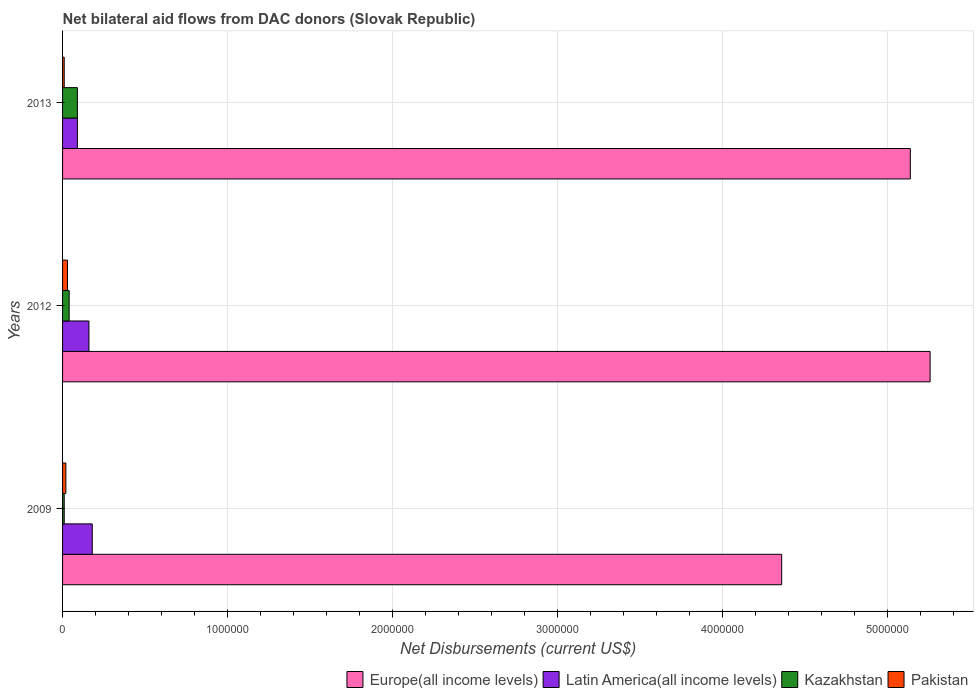How many different coloured bars are there?
Keep it short and to the point. 4. Are the number of bars per tick equal to the number of legend labels?
Provide a succinct answer. Yes. Are the number of bars on each tick of the Y-axis equal?
Your answer should be very brief. Yes. How many bars are there on the 1st tick from the bottom?
Provide a succinct answer. 4. In how many cases, is the number of bars for a given year not equal to the number of legend labels?
Keep it short and to the point. 0. Across all years, what is the maximum net bilateral aid flows in Kazakhstan?
Make the answer very short. 9.00e+04. In which year was the net bilateral aid flows in Pakistan maximum?
Your answer should be compact. 2012. In which year was the net bilateral aid flows in Pakistan minimum?
Give a very brief answer. 2013. What is the total net bilateral aid flows in Latin America(all income levels) in the graph?
Your response must be concise. 4.30e+05. What is the ratio of the net bilateral aid flows in Pakistan in 2009 to that in 2013?
Provide a succinct answer. 2. Is the difference between the net bilateral aid flows in Kazakhstan in 2009 and 2013 greater than the difference between the net bilateral aid flows in Latin America(all income levels) in 2009 and 2013?
Offer a very short reply. No. In how many years, is the net bilateral aid flows in Pakistan greater than the average net bilateral aid flows in Pakistan taken over all years?
Your response must be concise. 1. Is the sum of the net bilateral aid flows in Pakistan in 2009 and 2013 greater than the maximum net bilateral aid flows in Europe(all income levels) across all years?
Your answer should be very brief. No. Is it the case that in every year, the sum of the net bilateral aid flows in Kazakhstan and net bilateral aid flows in Pakistan is greater than the sum of net bilateral aid flows in Europe(all income levels) and net bilateral aid flows in Latin America(all income levels)?
Provide a short and direct response. No. What does the 3rd bar from the top in 2013 represents?
Your answer should be compact. Latin America(all income levels). What does the 3rd bar from the bottom in 2012 represents?
Your answer should be compact. Kazakhstan. Is it the case that in every year, the sum of the net bilateral aid flows in Latin America(all income levels) and net bilateral aid flows in Europe(all income levels) is greater than the net bilateral aid flows in Pakistan?
Your answer should be compact. Yes. How many bars are there?
Ensure brevity in your answer.  12. Are all the bars in the graph horizontal?
Keep it short and to the point. Yes. Are the values on the major ticks of X-axis written in scientific E-notation?
Your answer should be compact. No. Does the graph contain grids?
Provide a short and direct response. Yes. Where does the legend appear in the graph?
Give a very brief answer. Bottom right. How many legend labels are there?
Ensure brevity in your answer.  4. What is the title of the graph?
Provide a succinct answer. Net bilateral aid flows from DAC donors (Slovak Republic). Does "Singapore" appear as one of the legend labels in the graph?
Ensure brevity in your answer.  No. What is the label or title of the X-axis?
Provide a short and direct response. Net Disbursements (current US$). What is the Net Disbursements (current US$) of Europe(all income levels) in 2009?
Your answer should be compact. 4.36e+06. What is the Net Disbursements (current US$) of Latin America(all income levels) in 2009?
Provide a succinct answer. 1.80e+05. What is the Net Disbursements (current US$) in Kazakhstan in 2009?
Offer a terse response. 10000. What is the Net Disbursements (current US$) in Pakistan in 2009?
Make the answer very short. 2.00e+04. What is the Net Disbursements (current US$) of Europe(all income levels) in 2012?
Make the answer very short. 5.26e+06. What is the Net Disbursements (current US$) of Latin America(all income levels) in 2012?
Offer a very short reply. 1.60e+05. What is the Net Disbursements (current US$) of Kazakhstan in 2012?
Give a very brief answer. 4.00e+04. What is the Net Disbursements (current US$) of Pakistan in 2012?
Keep it short and to the point. 3.00e+04. What is the Net Disbursements (current US$) in Europe(all income levels) in 2013?
Provide a short and direct response. 5.14e+06. What is the Net Disbursements (current US$) in Pakistan in 2013?
Provide a succinct answer. 10000. Across all years, what is the maximum Net Disbursements (current US$) in Europe(all income levels)?
Keep it short and to the point. 5.26e+06. Across all years, what is the maximum Net Disbursements (current US$) of Kazakhstan?
Offer a terse response. 9.00e+04. Across all years, what is the minimum Net Disbursements (current US$) of Europe(all income levels)?
Give a very brief answer. 4.36e+06. Across all years, what is the minimum Net Disbursements (current US$) in Latin America(all income levels)?
Offer a very short reply. 9.00e+04. Across all years, what is the minimum Net Disbursements (current US$) in Kazakhstan?
Your answer should be very brief. 10000. What is the total Net Disbursements (current US$) in Europe(all income levels) in the graph?
Ensure brevity in your answer.  1.48e+07. What is the total Net Disbursements (current US$) of Kazakhstan in the graph?
Your response must be concise. 1.40e+05. What is the difference between the Net Disbursements (current US$) in Europe(all income levels) in 2009 and that in 2012?
Your answer should be very brief. -9.00e+05. What is the difference between the Net Disbursements (current US$) of Latin America(all income levels) in 2009 and that in 2012?
Your response must be concise. 2.00e+04. What is the difference between the Net Disbursements (current US$) in Kazakhstan in 2009 and that in 2012?
Keep it short and to the point. -3.00e+04. What is the difference between the Net Disbursements (current US$) in Pakistan in 2009 and that in 2012?
Ensure brevity in your answer.  -10000. What is the difference between the Net Disbursements (current US$) of Europe(all income levels) in 2009 and that in 2013?
Provide a short and direct response. -7.80e+05. What is the difference between the Net Disbursements (current US$) of Latin America(all income levels) in 2009 and that in 2013?
Keep it short and to the point. 9.00e+04. What is the difference between the Net Disbursements (current US$) of Latin America(all income levels) in 2012 and that in 2013?
Offer a terse response. 7.00e+04. What is the difference between the Net Disbursements (current US$) of Europe(all income levels) in 2009 and the Net Disbursements (current US$) of Latin America(all income levels) in 2012?
Your answer should be very brief. 4.20e+06. What is the difference between the Net Disbursements (current US$) in Europe(all income levels) in 2009 and the Net Disbursements (current US$) in Kazakhstan in 2012?
Give a very brief answer. 4.32e+06. What is the difference between the Net Disbursements (current US$) in Europe(all income levels) in 2009 and the Net Disbursements (current US$) in Pakistan in 2012?
Ensure brevity in your answer.  4.33e+06. What is the difference between the Net Disbursements (current US$) in Kazakhstan in 2009 and the Net Disbursements (current US$) in Pakistan in 2012?
Provide a short and direct response. -2.00e+04. What is the difference between the Net Disbursements (current US$) of Europe(all income levels) in 2009 and the Net Disbursements (current US$) of Latin America(all income levels) in 2013?
Your answer should be very brief. 4.27e+06. What is the difference between the Net Disbursements (current US$) of Europe(all income levels) in 2009 and the Net Disbursements (current US$) of Kazakhstan in 2013?
Offer a very short reply. 4.27e+06. What is the difference between the Net Disbursements (current US$) of Europe(all income levels) in 2009 and the Net Disbursements (current US$) of Pakistan in 2013?
Ensure brevity in your answer.  4.35e+06. What is the difference between the Net Disbursements (current US$) in Europe(all income levels) in 2012 and the Net Disbursements (current US$) in Latin America(all income levels) in 2013?
Your response must be concise. 5.17e+06. What is the difference between the Net Disbursements (current US$) in Europe(all income levels) in 2012 and the Net Disbursements (current US$) in Kazakhstan in 2013?
Give a very brief answer. 5.17e+06. What is the difference between the Net Disbursements (current US$) of Europe(all income levels) in 2012 and the Net Disbursements (current US$) of Pakistan in 2013?
Keep it short and to the point. 5.25e+06. What is the difference between the Net Disbursements (current US$) in Latin America(all income levels) in 2012 and the Net Disbursements (current US$) in Kazakhstan in 2013?
Provide a short and direct response. 7.00e+04. What is the average Net Disbursements (current US$) in Europe(all income levels) per year?
Provide a short and direct response. 4.92e+06. What is the average Net Disbursements (current US$) of Latin America(all income levels) per year?
Your answer should be compact. 1.43e+05. What is the average Net Disbursements (current US$) of Kazakhstan per year?
Provide a succinct answer. 4.67e+04. In the year 2009, what is the difference between the Net Disbursements (current US$) of Europe(all income levels) and Net Disbursements (current US$) of Latin America(all income levels)?
Offer a terse response. 4.18e+06. In the year 2009, what is the difference between the Net Disbursements (current US$) of Europe(all income levels) and Net Disbursements (current US$) of Kazakhstan?
Give a very brief answer. 4.35e+06. In the year 2009, what is the difference between the Net Disbursements (current US$) of Europe(all income levels) and Net Disbursements (current US$) of Pakistan?
Provide a succinct answer. 4.34e+06. In the year 2009, what is the difference between the Net Disbursements (current US$) of Kazakhstan and Net Disbursements (current US$) of Pakistan?
Keep it short and to the point. -10000. In the year 2012, what is the difference between the Net Disbursements (current US$) in Europe(all income levels) and Net Disbursements (current US$) in Latin America(all income levels)?
Offer a very short reply. 5.10e+06. In the year 2012, what is the difference between the Net Disbursements (current US$) in Europe(all income levels) and Net Disbursements (current US$) in Kazakhstan?
Provide a succinct answer. 5.22e+06. In the year 2012, what is the difference between the Net Disbursements (current US$) in Europe(all income levels) and Net Disbursements (current US$) in Pakistan?
Give a very brief answer. 5.23e+06. In the year 2012, what is the difference between the Net Disbursements (current US$) in Latin America(all income levels) and Net Disbursements (current US$) in Pakistan?
Keep it short and to the point. 1.30e+05. In the year 2013, what is the difference between the Net Disbursements (current US$) in Europe(all income levels) and Net Disbursements (current US$) in Latin America(all income levels)?
Provide a short and direct response. 5.05e+06. In the year 2013, what is the difference between the Net Disbursements (current US$) in Europe(all income levels) and Net Disbursements (current US$) in Kazakhstan?
Your answer should be compact. 5.05e+06. In the year 2013, what is the difference between the Net Disbursements (current US$) of Europe(all income levels) and Net Disbursements (current US$) of Pakistan?
Provide a succinct answer. 5.13e+06. What is the ratio of the Net Disbursements (current US$) in Europe(all income levels) in 2009 to that in 2012?
Give a very brief answer. 0.83. What is the ratio of the Net Disbursements (current US$) in Latin America(all income levels) in 2009 to that in 2012?
Provide a succinct answer. 1.12. What is the ratio of the Net Disbursements (current US$) in Kazakhstan in 2009 to that in 2012?
Give a very brief answer. 0.25. What is the ratio of the Net Disbursements (current US$) of Europe(all income levels) in 2009 to that in 2013?
Provide a short and direct response. 0.85. What is the ratio of the Net Disbursements (current US$) in Europe(all income levels) in 2012 to that in 2013?
Your answer should be compact. 1.02. What is the ratio of the Net Disbursements (current US$) of Latin America(all income levels) in 2012 to that in 2013?
Make the answer very short. 1.78. What is the ratio of the Net Disbursements (current US$) of Kazakhstan in 2012 to that in 2013?
Your answer should be compact. 0.44. What is the difference between the highest and the second highest Net Disbursements (current US$) in Latin America(all income levels)?
Make the answer very short. 2.00e+04. What is the difference between the highest and the lowest Net Disbursements (current US$) in Kazakhstan?
Give a very brief answer. 8.00e+04. What is the difference between the highest and the lowest Net Disbursements (current US$) of Pakistan?
Your answer should be very brief. 2.00e+04. 